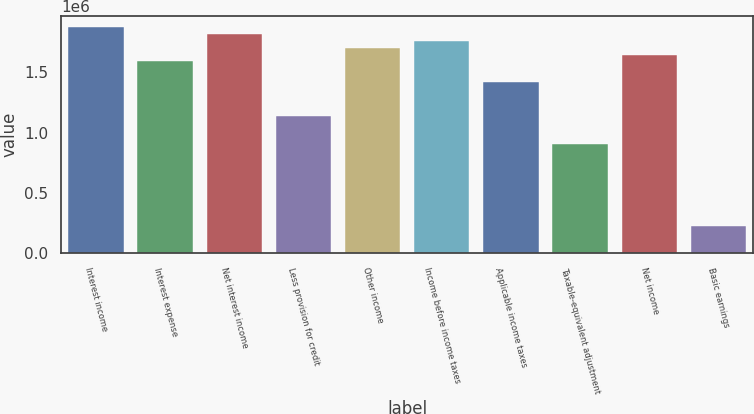Convert chart to OTSL. <chart><loc_0><loc_0><loc_500><loc_500><bar_chart><fcel>Interest income<fcel>Interest expense<fcel>Net interest income<fcel>Less provision for credit<fcel>Other income<fcel>Income before income taxes<fcel>Applicable income taxes<fcel>Taxable-equivalent adjustment<fcel>Net income<fcel>Basic earnings<nl><fcel>1.87545e+06<fcel>1.59129e+06<fcel>1.81862e+06<fcel>1.13664e+06<fcel>1.70496e+06<fcel>1.76179e+06<fcel>1.4208e+06<fcel>909310<fcel>1.64812e+06<fcel>227328<nl></chart> 